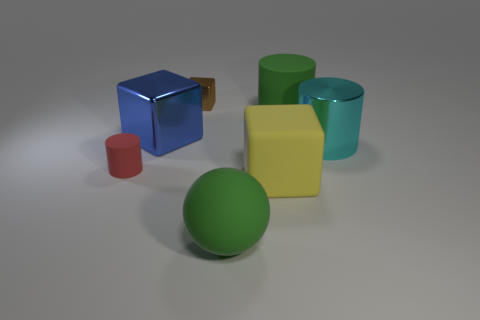Does the rubber cylinder that is on the left side of the green matte cylinder have the same color as the large object to the left of the sphere?
Your response must be concise. No. There is a cylinder to the left of the big metallic cube; what is its material?
Offer a terse response. Rubber. What color is the cube that is the same material as the ball?
Give a very brief answer. Yellow. What number of brown cylinders are the same size as the matte ball?
Your answer should be compact. 0. Do the matte cylinder that is in front of the green rubber cylinder and the large blue metal cube have the same size?
Your answer should be compact. No. What shape is the metallic object that is both in front of the brown block and left of the large matte cylinder?
Your answer should be very brief. Cube. There is a cyan object; are there any brown objects in front of it?
Offer a terse response. No. Is there anything else that has the same shape as the large blue metal object?
Provide a succinct answer. Yes. Does the red matte object have the same shape as the tiny brown shiny thing?
Keep it short and to the point. No. Are there the same number of tiny metallic cubes on the right side of the small metallic cube and green matte balls that are to the right of the big rubber cylinder?
Make the answer very short. Yes. 